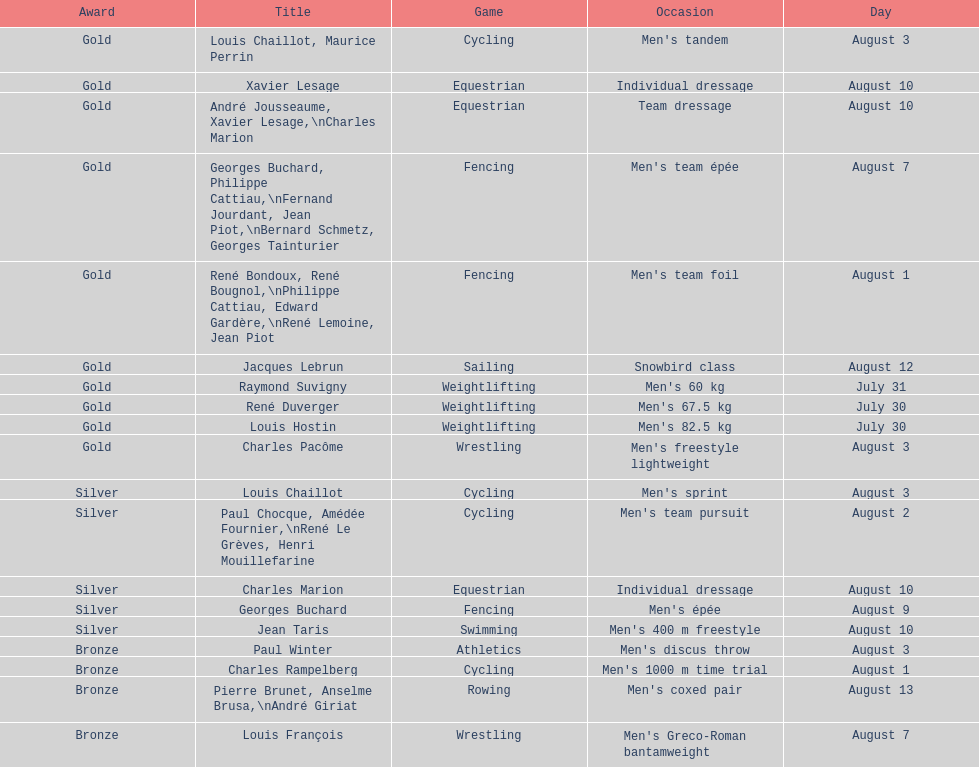What sport is listed first? Cycling. 